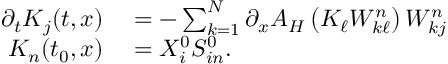Convert formula to latex. <formula><loc_0><loc_0><loc_500><loc_500>\begin{array} { r l } { \partial _ { t } K _ { j } ( t , x ) } & = - \sum _ { k = 1 } ^ { N } \partial _ { x } A _ { H } \left ( K _ { \ell } W _ { k \ell } ^ { n } \right ) W _ { k j } ^ { n } } \\ { K _ { n } ( t _ { 0 } , x ) } & = X _ { i } ^ { 0 } S _ { i n } ^ { 0 } . } \end{array}</formula> 